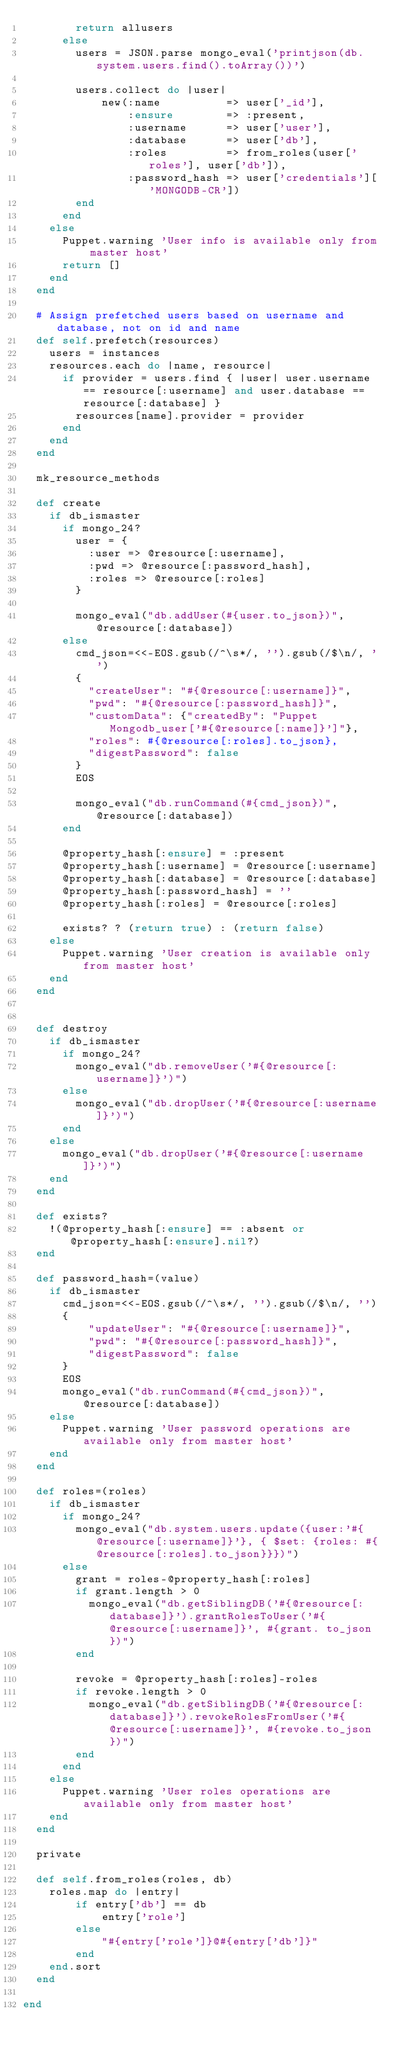Convert code to text. <code><loc_0><loc_0><loc_500><loc_500><_Ruby_>        return allusers
      else
        users = JSON.parse mongo_eval('printjson(db.system.users.find().toArray())')

        users.collect do |user|
            new(:name          => user['_id'],
                :ensure        => :present,
                :username      => user['user'],
                :database      => user['db'],
                :roles         => from_roles(user['roles'], user['db']),
                :password_hash => user['credentials']['MONGODB-CR'])
        end
      end
    else
      Puppet.warning 'User info is available only from master host'
      return []
    end
  end

  # Assign prefetched users based on username and database, not on id and name
  def self.prefetch(resources)
    users = instances
    resources.each do |name, resource|
      if provider = users.find { |user| user.username == resource[:username] and user.database == resource[:database] }
        resources[name].provider = provider
      end
    end
  end

  mk_resource_methods

  def create
    if db_ismaster
      if mongo_24?
        user = {
          :user => @resource[:username],
          :pwd => @resource[:password_hash],
          :roles => @resource[:roles]
        }

        mongo_eval("db.addUser(#{user.to_json})", @resource[:database])
      else
        cmd_json=<<-EOS.gsub(/^\s*/, '').gsub(/$\n/, '')
        {
          "createUser": "#{@resource[:username]}",
          "pwd": "#{@resource[:password_hash]}",
          "customData": {"createdBy": "Puppet Mongodb_user['#{@resource[:name]}']"},
          "roles": #{@resource[:roles].to_json},
          "digestPassword": false
        }
        EOS

        mongo_eval("db.runCommand(#{cmd_json})", @resource[:database])
      end

      @property_hash[:ensure] = :present
      @property_hash[:username] = @resource[:username]
      @property_hash[:database] = @resource[:database]
      @property_hash[:password_hash] = ''
      @property_hash[:roles] = @resource[:roles]

      exists? ? (return true) : (return false)
    else
      Puppet.warning 'User creation is available only from master host'
    end
  end


  def destroy
    if db_ismaster
      if mongo_24?
        mongo_eval("db.removeUser('#{@resource[:username]}')")
      else
        mongo_eval("db.dropUser('#{@resource[:username]}')")
      end
    else
      mongo_eval("db.dropUser('#{@resource[:username]}')")
    end
  end

  def exists?
    !(@property_hash[:ensure] == :absent or @property_hash[:ensure].nil?)
  end

  def password_hash=(value)
    if db_ismaster
      cmd_json=<<-EOS.gsub(/^\s*/, '').gsub(/$\n/, '')
      {
          "updateUser": "#{@resource[:username]}",
          "pwd": "#{@resource[:password_hash]}",
          "digestPassword": false
      }
      EOS
      mongo_eval("db.runCommand(#{cmd_json})", @resource[:database])
    else
      Puppet.warning 'User password operations are available only from master host'
    end
  end

  def roles=(roles)
    if db_ismaster
      if mongo_24?
        mongo_eval("db.system.users.update({user:'#{@resource[:username]}'}, { $set: {roles: #{@resource[:roles].to_json}}})")
      else
        grant = roles-@property_hash[:roles]
        if grant.length > 0
          mongo_eval("db.getSiblingDB('#{@resource[:database]}').grantRolesToUser('#{@resource[:username]}', #{grant. to_json})")
        end

        revoke = @property_hash[:roles]-roles
        if revoke.length > 0
          mongo_eval("db.getSiblingDB('#{@resource[:database]}').revokeRolesFromUser('#{@resource[:username]}', #{revoke.to_json})")
        end
      end
    else
      Puppet.warning 'User roles operations are available only from master host'
    end
  end

  private

  def self.from_roles(roles, db)
    roles.map do |entry|
        if entry['db'] == db
            entry['role']
        else
            "#{entry['role']}@#{entry['db']}"
        end
    end.sort
  end

end
</code> 